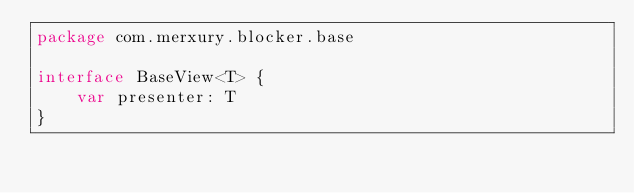<code> <loc_0><loc_0><loc_500><loc_500><_Kotlin_>package com.merxury.blocker.base

interface BaseView<T> {
    var presenter: T
}</code> 